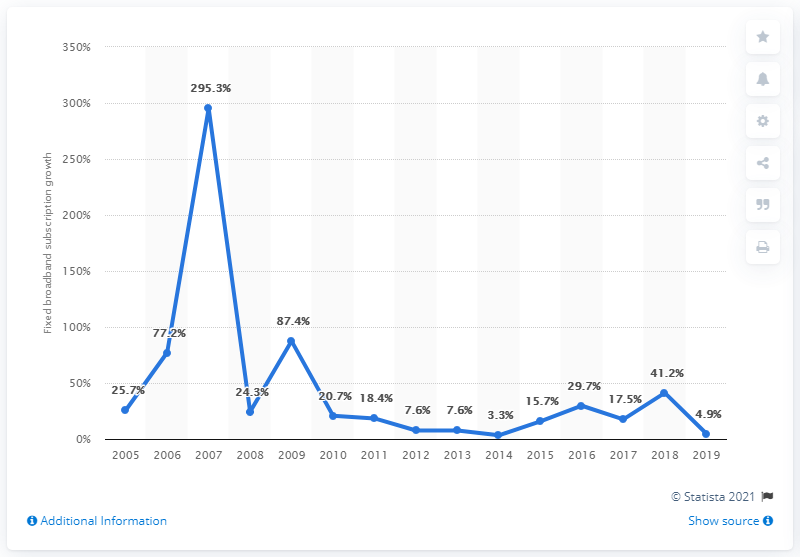Identify some key points in this picture. There are 7 years out of the total years that have a percentage below 20%. Indonesia's fixed broadband subscriptions grew by 41.2% in 2019. In 2007, there were the highest number of subscriptions. 